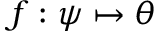Convert formula to latex. <formula><loc_0><loc_0><loc_500><loc_500>f \colon \psi \mapsto \theta</formula> 